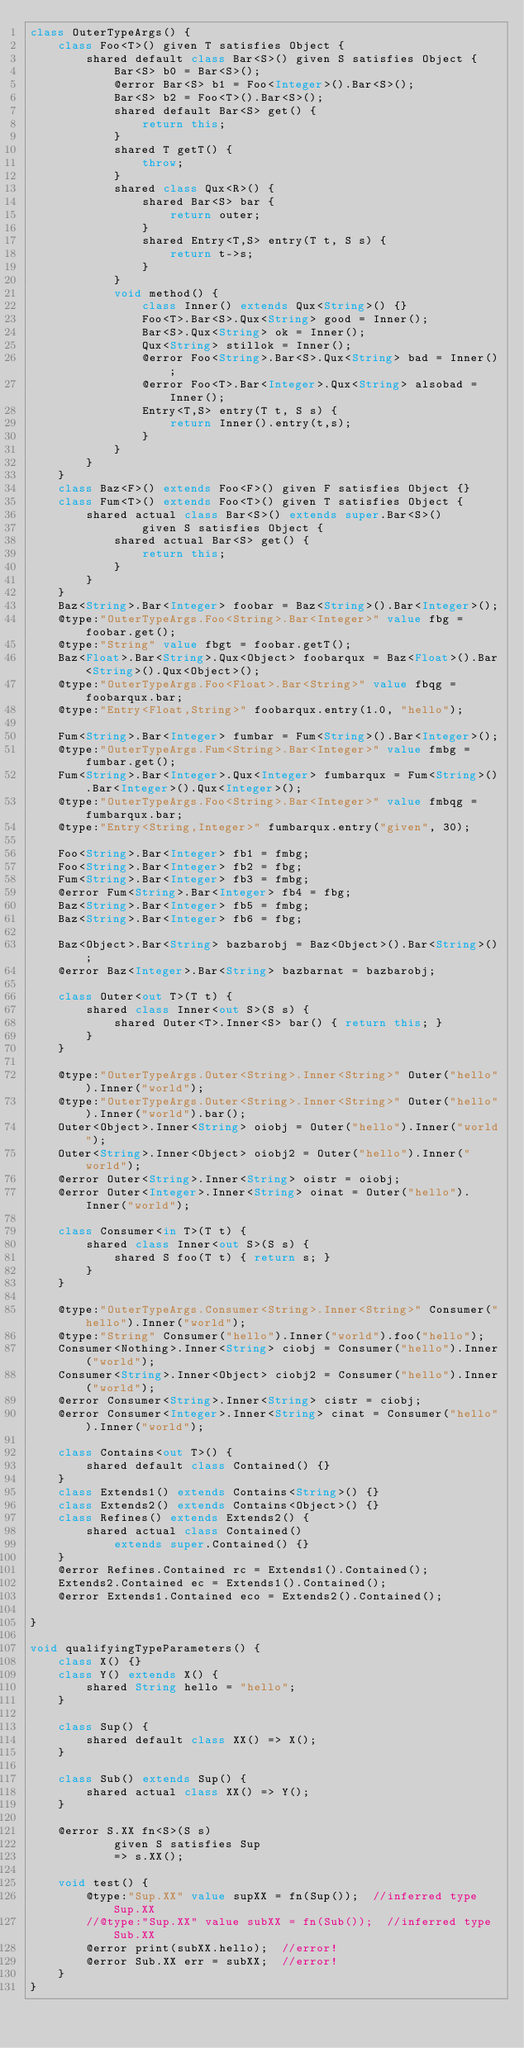Convert code to text. <code><loc_0><loc_0><loc_500><loc_500><_Ceylon_>class OuterTypeArgs() {
	class Foo<T>() given T satisfies Object {
		shared default class Bar<S>() given S satisfies Object {
			Bar<S> b0 = Bar<S>();
			@error Bar<S> b1 = Foo<Integer>().Bar<S>();
			Bar<S> b2 = Foo<T>().Bar<S>();
			shared default Bar<S> get() {
				return this;
			}
			shared T getT() {
				throw;
			}
			shared class Qux<R>() {
				shared Bar<S> bar {
					return outer;
				}
				shared Entry<T,S> entry(T t, S s) {
					return t->s;
				}
			}
			void method() {
				class Inner() extends Qux<String>() {}
				Foo<T>.Bar<S>.Qux<String> good = Inner();
				Bar<S>.Qux<String> ok = Inner();
				Qux<String> stillok = Inner();
				@error Foo<String>.Bar<S>.Qux<String> bad = Inner();
				@error Foo<T>.Bar<Integer>.Qux<String> alsobad = Inner();
				Entry<T,S> entry(T t, S s) {
					return Inner().entry(t,s);
				}
			}
		}
	}
	class Baz<F>() extends Foo<F>() given F satisfies Object {}
	class Fum<T>() extends Foo<T>() given T satisfies Object {
		shared actual class Bar<S>() extends super.Bar<S>() 
		        given S satisfies Object {
			shared actual Bar<S> get() {
				return this;
			}
		}
	}
	Baz<String>.Bar<Integer> foobar = Baz<String>().Bar<Integer>();
	@type:"OuterTypeArgs.Foo<String>.Bar<Integer>" value fbg = foobar.get();
	@type:"String" value fbgt = foobar.getT();
	Baz<Float>.Bar<String>.Qux<Object> foobarqux = Baz<Float>().Bar<String>().Qux<Object>();
	@type:"OuterTypeArgs.Foo<Float>.Bar<String>" value fbqg = foobarqux.bar;
	@type:"Entry<Float,String>" foobarqux.entry(1.0, "hello");

	Fum<String>.Bar<Integer> fumbar = Fum<String>().Bar<Integer>();
	@type:"OuterTypeArgs.Fum<String>.Bar<Integer>" value fmbg = fumbar.get();
	Fum<String>.Bar<Integer>.Qux<Integer> fumbarqux = Fum<String>().Bar<Integer>().Qux<Integer>();
	@type:"OuterTypeArgs.Foo<String>.Bar<Integer>" value fmbqg = fumbarqux.bar;
	@type:"Entry<String,Integer>" fumbarqux.entry("given", 30);
	
	Foo<String>.Bar<Integer> fb1 = fmbg;
	Foo<String>.Bar<Integer> fb2 = fbg; 
	Fum<String>.Bar<Integer> fb3 = fmbg;
	@error Fum<String>.Bar<Integer> fb4 = fbg; 
	Baz<String>.Bar<Integer> fb5 = fmbg;
	Baz<String>.Bar<Integer> fb6 = fbg;
	
	Baz<Object>.Bar<String> bazbarobj = Baz<Object>().Bar<String>();
	@error Baz<Integer>.Bar<String> bazbarnat = bazbarobj;
	
	class Outer<out T>(T t) {
		shared class Inner<out S>(S s) {
			shared Outer<T>.Inner<S> bar() { return this; }
		}
	}
	
	@type:"OuterTypeArgs.Outer<String>.Inner<String>" Outer("hello").Inner("world");
	@type:"OuterTypeArgs.Outer<String>.Inner<String>" Outer("hello").Inner("world").bar();
	Outer<Object>.Inner<String> oiobj = Outer("hello").Inner("world");
	Outer<String>.Inner<Object> oiobj2 = Outer("hello").Inner("world");
	@error Outer<String>.Inner<String> oistr = oiobj;
	@error Outer<Integer>.Inner<String> oinat = Outer("hello").Inner("world");

	class Consumer<in T>(T t) {
		shared class Inner<out S>(S s) {
			shared S foo(T t) { return s; }
		}
	}
	
	@type:"OuterTypeArgs.Consumer<String>.Inner<String>" Consumer("hello").Inner("world");
	@type:"String" Consumer("hello").Inner("world").foo("hello");
	Consumer<Nothing>.Inner<String> ciobj = Consumer("hello").Inner("world");
	Consumer<String>.Inner<Object> ciobj2 = Consumer("hello").Inner("world");
	@error Consumer<String>.Inner<String> cistr = ciobj;
	@error Consumer<Integer>.Inner<String> cinat = Consumer("hello").Inner("world");
	
	class Contains<out T>() {
	    shared default class Contained() {}
	}
	class Extends1() extends Contains<String>() {}
    class Extends2() extends Contains<Object>() {}
    class Refines() extends Extends2() {
        shared actual class Contained() 
            extends super.Contained() {}
    }
    @error Refines.Contained rc = Extends1().Contained(); 
    Extends2.Contained ec = Extends1().Contained(); 
    @error Extends1.Contained eco = Extends2().Contained(); 

}

void qualifyingTypeParameters() {
    class X() {}
    class Y() extends X() {
        shared String hello = "hello";
    }
    
    class Sup() {
        shared default class XX() => X();
    }
    
    class Sub() extends Sup() {
        shared actual class XX() => Y();
    }
    
    @error S.XX fn<S>(S s) 
            given S satisfies Sup 
            => s.XX();
    
    void test() {
        @type:"Sup.XX" value supXX = fn(Sup());  //inferred type Sup.XX
        //@type:"Sup.XX" value subXX = fn(Sub());  //inferred type Sub.XX
        @error print(subXX.hello);  //error!
        @error Sub.XX err = subXX;  //error!
    }
}</code> 